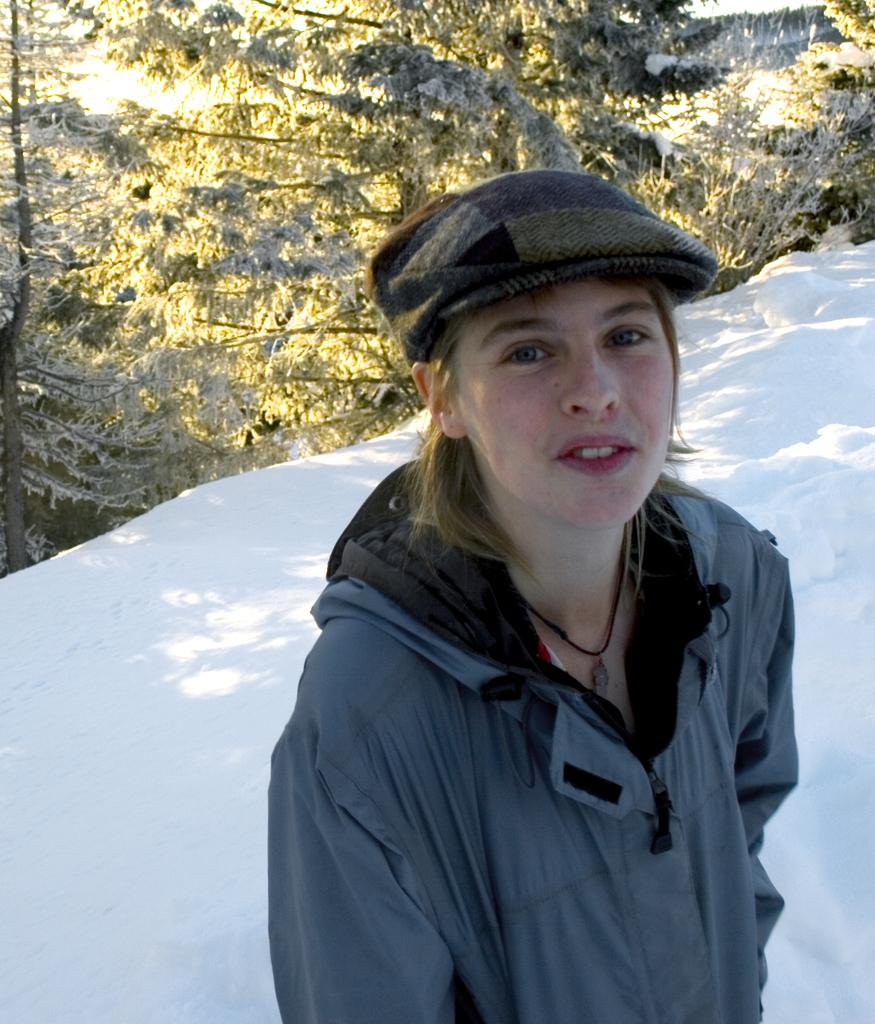Who is the main subject in the foreground of the image? There is a woman standing in the foreground of the image. What is the woman standing on? The woman is standing on an ice road. What can be seen in the background of the image? There are trees and snow in the background of the image. What might be the weather condition during the time the image was taken? The image may have been taken during a sunny day. What type of poison is the woman holding in the image? There is no poison present in the image; the woman is not holding anything. What kind of trouble is the woman facing in the image? There is no indication of trouble in the image; the woman is simply standing on an ice road. 